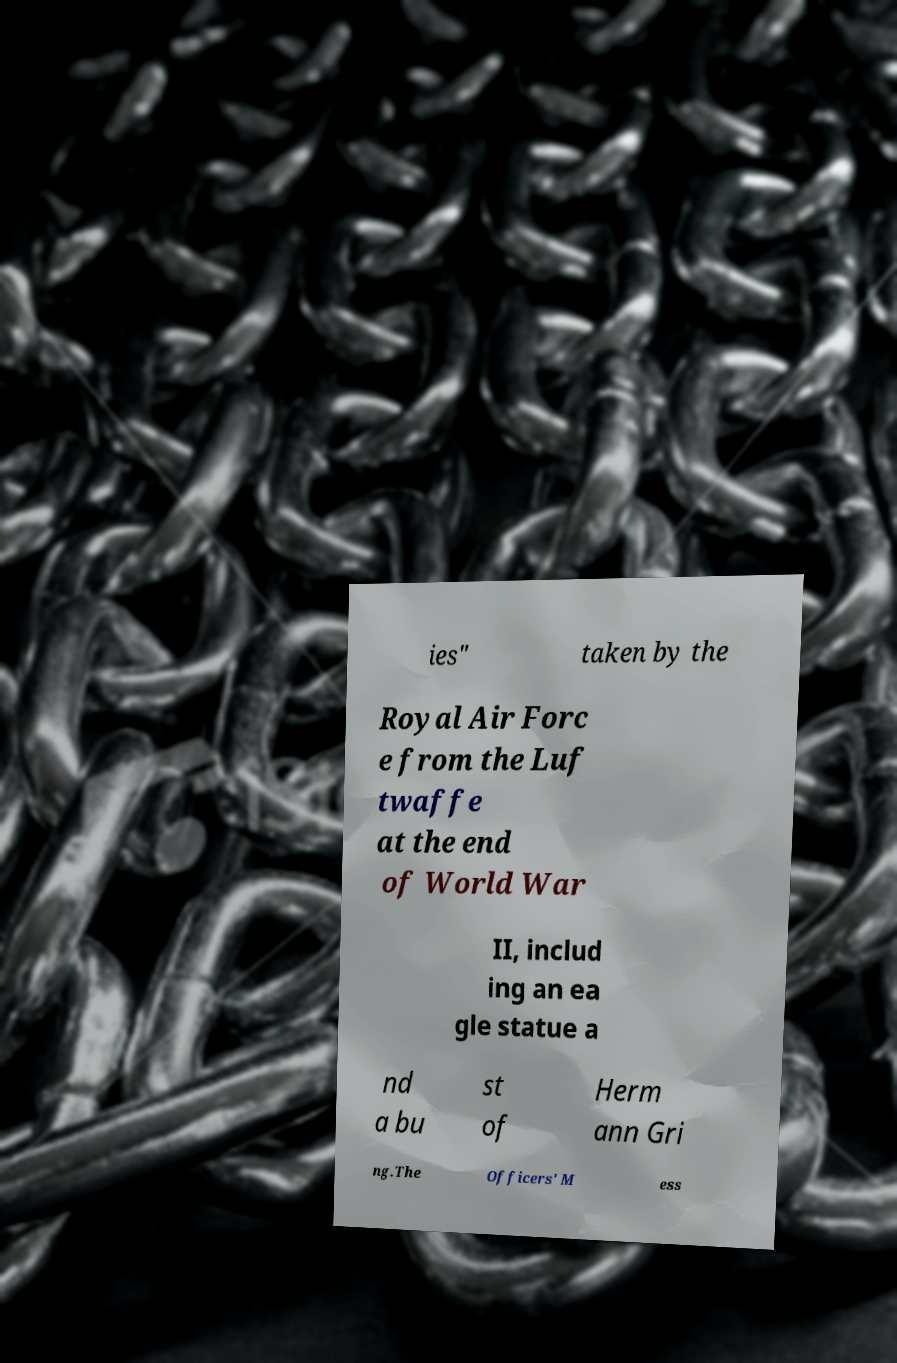Could you extract and type out the text from this image? ies" taken by the Royal Air Forc e from the Luf twaffe at the end of World War II, includ ing an ea gle statue a nd a bu st of Herm ann Gri ng.The Officers' M ess 